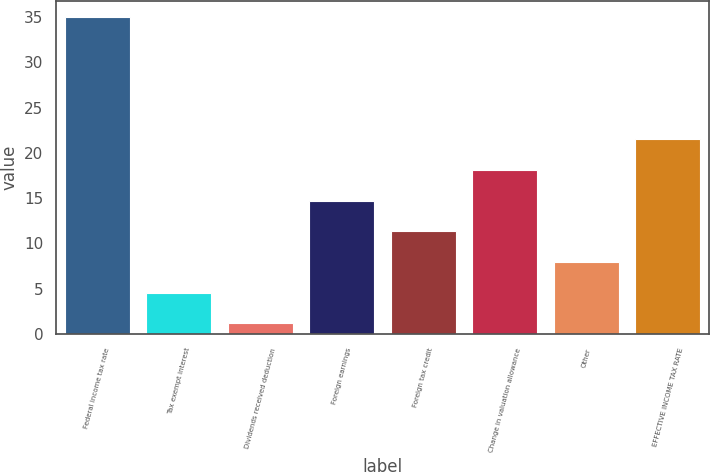Convert chart to OTSL. <chart><loc_0><loc_0><loc_500><loc_500><bar_chart><fcel>Federal income tax rate<fcel>Tax exempt interest<fcel>Dividends received deduction<fcel>Foreign earnings<fcel>Foreign tax credit<fcel>Change in valuation allowance<fcel>Other<fcel>EFFECTIVE INCOME TAX RATE<nl><fcel>35<fcel>4.58<fcel>1.2<fcel>14.72<fcel>11.34<fcel>18.1<fcel>7.96<fcel>21.48<nl></chart> 